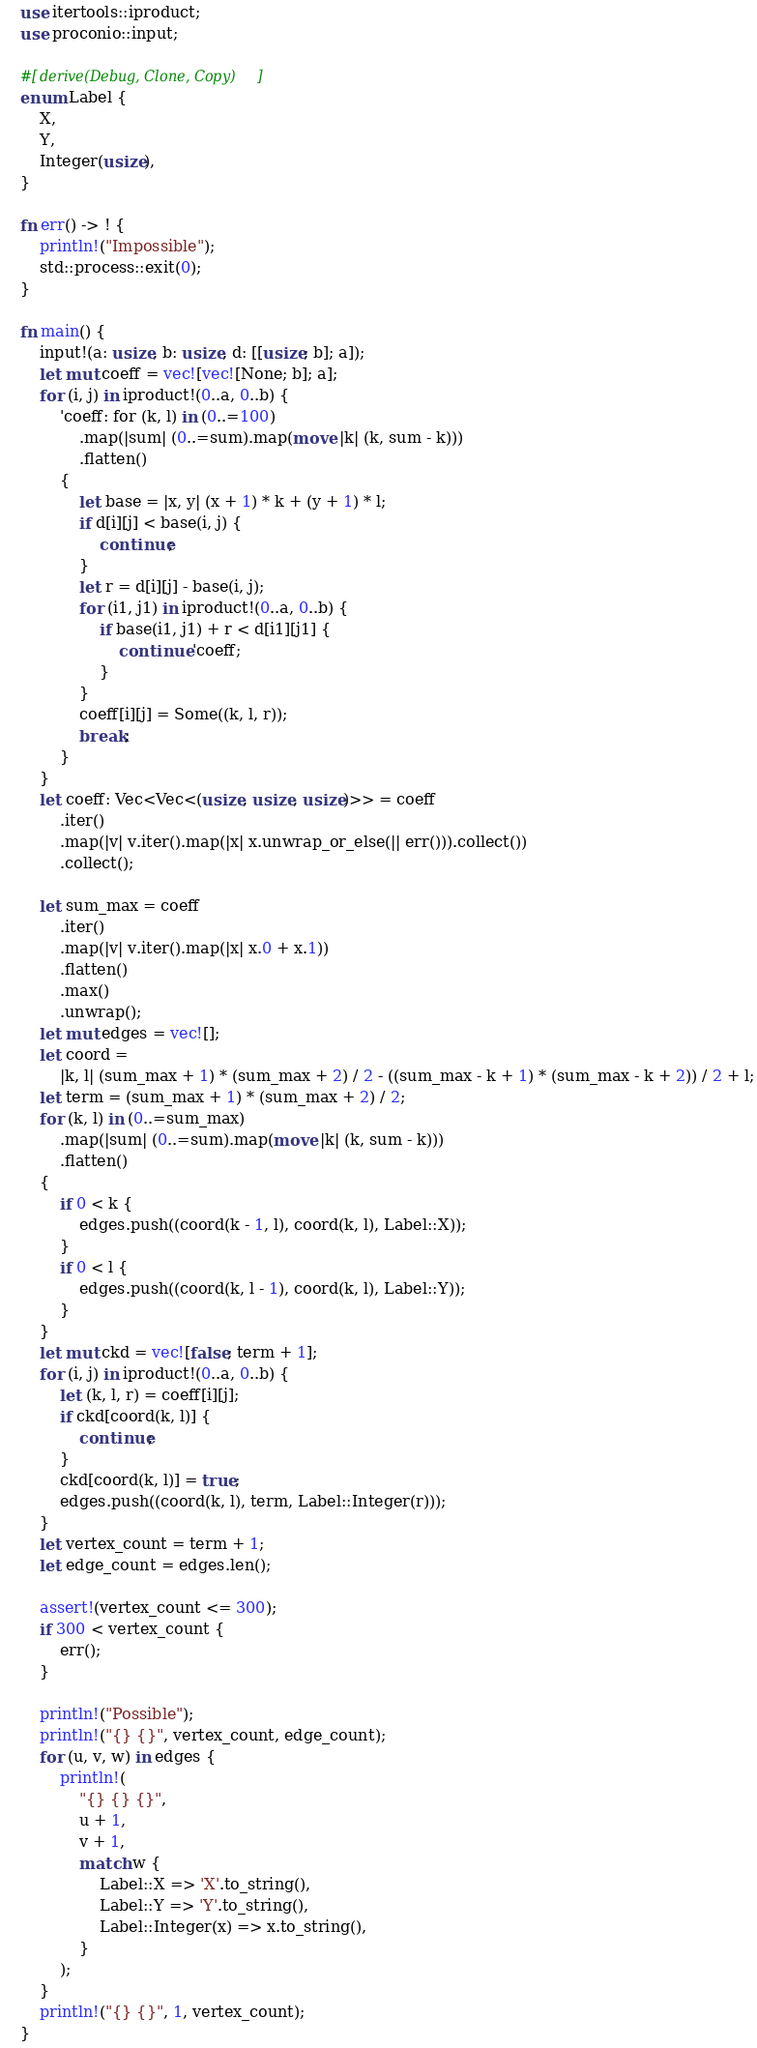<code> <loc_0><loc_0><loc_500><loc_500><_Rust_>use itertools::iproduct;
use proconio::input;

#[derive(Debug, Clone, Copy)]
enum Label {
    X,
    Y,
    Integer(usize),
}

fn err() -> ! {
    println!("Impossible");
    std::process::exit(0);
}

fn main() {
    input!(a: usize, b: usize, d: [[usize; b]; a]);
    let mut coeff = vec![vec![None; b]; a];
    for (i, j) in iproduct!(0..a, 0..b) {
        'coeff: for (k, l) in (0..=100)
            .map(|sum| (0..=sum).map(move |k| (k, sum - k)))
            .flatten()
        {
            let base = |x, y| (x + 1) * k + (y + 1) * l;
            if d[i][j] < base(i, j) {
                continue;
            }
            let r = d[i][j] - base(i, j);
            for (i1, j1) in iproduct!(0..a, 0..b) {
                if base(i1, j1) + r < d[i1][j1] {
                    continue 'coeff;
                }
            }
            coeff[i][j] = Some((k, l, r));
            break;
        }
    }
    let coeff: Vec<Vec<(usize, usize, usize)>> = coeff
        .iter()
        .map(|v| v.iter().map(|x| x.unwrap_or_else(|| err())).collect())
        .collect();

    let sum_max = coeff
        .iter()
        .map(|v| v.iter().map(|x| x.0 + x.1))
        .flatten()
        .max()
        .unwrap();
    let mut edges = vec![];
    let coord =
        |k, l| (sum_max + 1) * (sum_max + 2) / 2 - ((sum_max - k + 1) * (sum_max - k + 2)) / 2 + l;
    let term = (sum_max + 1) * (sum_max + 2) / 2;
    for (k, l) in (0..=sum_max)
        .map(|sum| (0..=sum).map(move |k| (k, sum - k)))
        .flatten()
    {
        if 0 < k {
            edges.push((coord(k - 1, l), coord(k, l), Label::X));
        }
        if 0 < l {
            edges.push((coord(k, l - 1), coord(k, l), Label::Y));
        }
    }
    let mut ckd = vec![false; term + 1];
    for (i, j) in iproduct!(0..a, 0..b) {
        let (k, l, r) = coeff[i][j];
        if ckd[coord(k, l)] {
            continue;
        }
        ckd[coord(k, l)] = true;
        edges.push((coord(k, l), term, Label::Integer(r)));
    }
    let vertex_count = term + 1;
    let edge_count = edges.len();

    assert!(vertex_count <= 300);
    if 300 < vertex_count {
        err();
    }

    println!("Possible");
    println!("{} {}", vertex_count, edge_count);
    for (u, v, w) in edges {
        println!(
            "{} {} {}",
            u + 1,
            v + 1,
            match w {
                Label::X => 'X'.to_string(),
                Label::Y => 'Y'.to_string(),
                Label::Integer(x) => x.to_string(),
            }
        );
    }
    println!("{} {}", 1, vertex_count);
}
</code> 